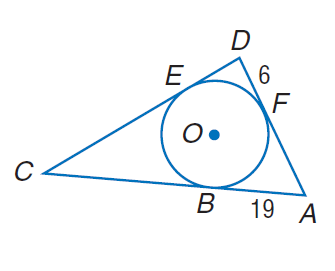Question: Triangle A D C is circumscribed about \odot O. Find the perimeter of \triangle A D C if E C = D E + A F.
Choices:
A. 6
B. 19
C. 25
D. 100
Answer with the letter. Answer: D 